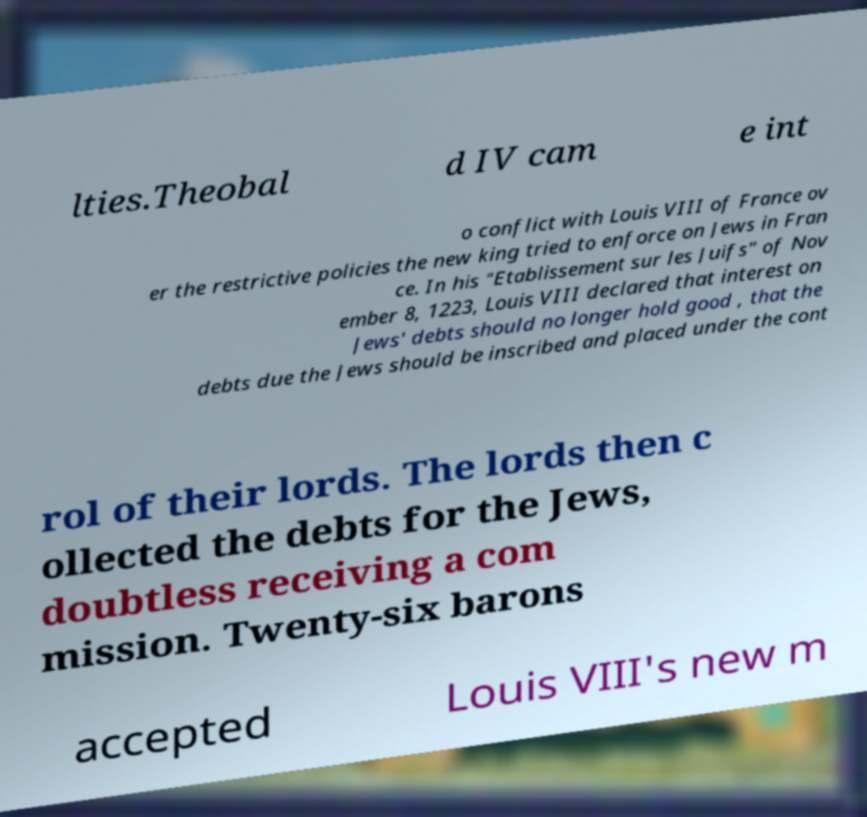Can you read and provide the text displayed in the image?This photo seems to have some interesting text. Can you extract and type it out for me? lties.Theobal d IV cam e int o conflict with Louis VIII of France ov er the restrictive policies the new king tried to enforce on Jews in Fran ce. In his "Etablissement sur les Juifs" of Nov ember 8, 1223, Louis VIII declared that interest on Jews' debts should no longer hold good , that the debts due the Jews should be inscribed and placed under the cont rol of their lords. The lords then c ollected the debts for the Jews, doubtless receiving a com mission. Twenty-six barons accepted Louis VIII's new m 